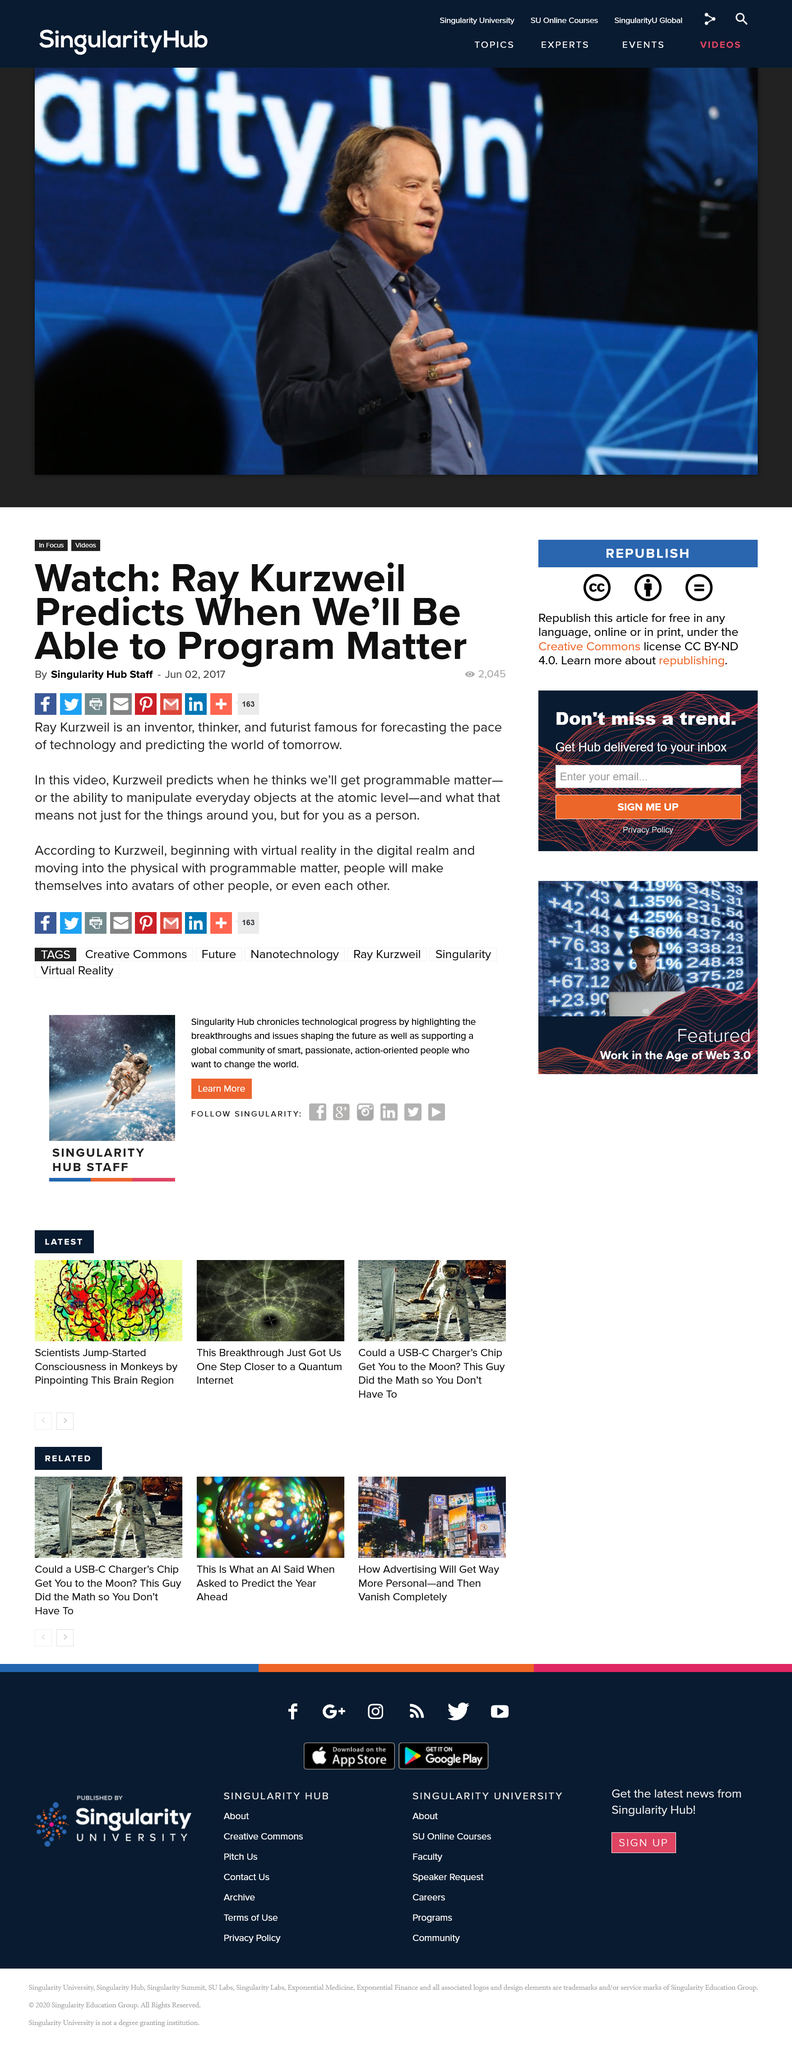Outline some significant characteristics in this image. The article was written on June 2, 2017. The picture is of Ray Kurzweil and the article was written by Singularity Hub Staff. Ray Kurzweil is a renowned inventor, thinker, and futurist who has accurately predicted the rapid pace of technological advancement and envisioned the world of the future. 